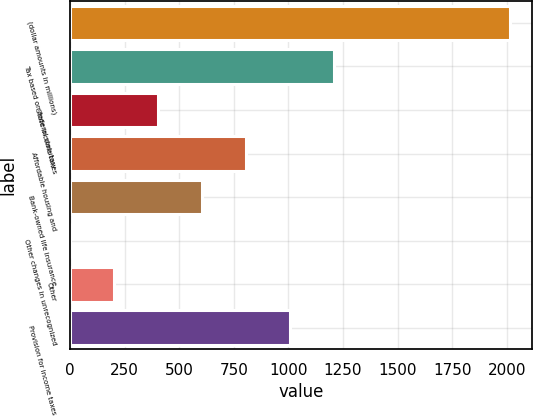<chart> <loc_0><loc_0><loc_500><loc_500><bar_chart><fcel>(dollar amounts in millions)<fcel>Tax based on federal statutory<fcel>State income taxes<fcel>Affordable housing and<fcel>Bank-owned life insurance<fcel>Other changes in unrecognized<fcel>Other<fcel>Provision for income taxes<nl><fcel>2013<fcel>1207.88<fcel>402.76<fcel>805.32<fcel>604.04<fcel>0.2<fcel>201.48<fcel>1006.6<nl></chart> 